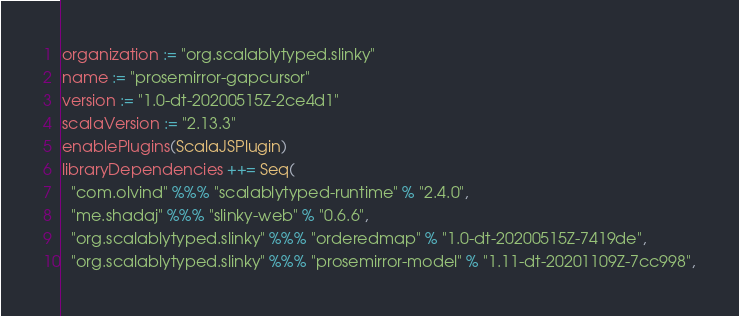Convert code to text. <code><loc_0><loc_0><loc_500><loc_500><_Scala_>organization := "org.scalablytyped.slinky"
name := "prosemirror-gapcursor"
version := "1.0-dt-20200515Z-2ce4d1"
scalaVersion := "2.13.3"
enablePlugins(ScalaJSPlugin)
libraryDependencies ++= Seq(
  "com.olvind" %%% "scalablytyped-runtime" % "2.4.0",
  "me.shadaj" %%% "slinky-web" % "0.6.6",
  "org.scalablytyped.slinky" %%% "orderedmap" % "1.0-dt-20200515Z-7419de",
  "org.scalablytyped.slinky" %%% "prosemirror-model" % "1.11-dt-20201109Z-7cc998",</code> 